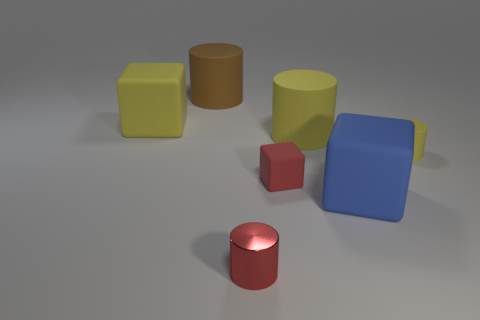Add 2 big cylinders. How many objects exist? 9 Subtract all cylinders. How many objects are left? 3 Add 6 big brown rubber cylinders. How many big brown rubber cylinders are left? 7 Add 3 small blue matte cylinders. How many small blue matte cylinders exist? 3 Subtract 0 blue balls. How many objects are left? 7 Subtract all red rubber things. Subtract all big blue matte objects. How many objects are left? 5 